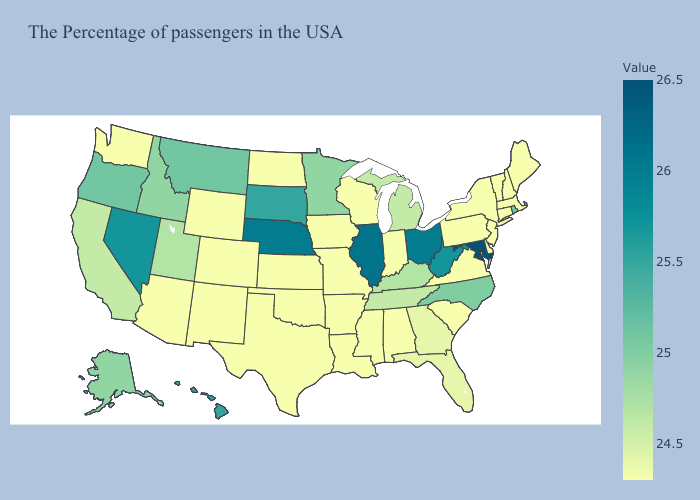Does Alabama have a lower value than North Carolina?
Short answer required. Yes. Does Maryland have the lowest value in the South?
Answer briefly. No. Does New York have the lowest value in the USA?
Short answer required. Yes. Does the map have missing data?
Quick response, please. No. Which states hav the highest value in the South?
Keep it brief. Maryland. Among the states that border Wisconsin , which have the highest value?
Concise answer only. Illinois. 